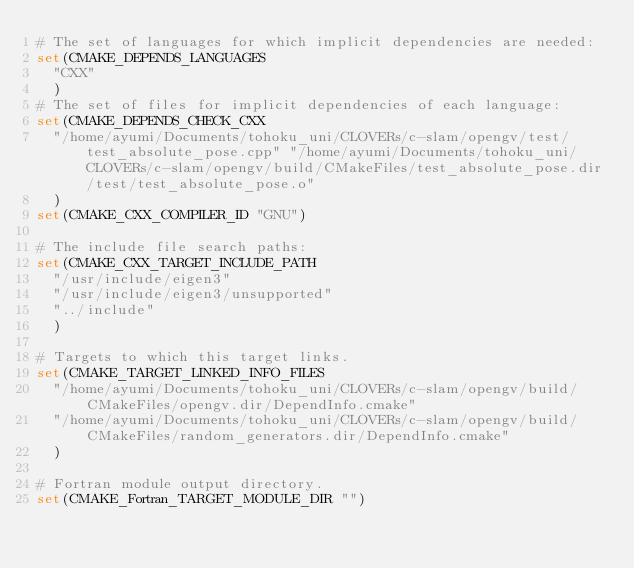<code> <loc_0><loc_0><loc_500><loc_500><_CMake_># The set of languages for which implicit dependencies are needed:
set(CMAKE_DEPENDS_LANGUAGES
  "CXX"
  )
# The set of files for implicit dependencies of each language:
set(CMAKE_DEPENDS_CHECK_CXX
  "/home/ayumi/Documents/tohoku_uni/CLOVERs/c-slam/opengv/test/test_absolute_pose.cpp" "/home/ayumi/Documents/tohoku_uni/CLOVERs/c-slam/opengv/build/CMakeFiles/test_absolute_pose.dir/test/test_absolute_pose.o"
  )
set(CMAKE_CXX_COMPILER_ID "GNU")

# The include file search paths:
set(CMAKE_CXX_TARGET_INCLUDE_PATH
  "/usr/include/eigen3"
  "/usr/include/eigen3/unsupported"
  "../include"
  )

# Targets to which this target links.
set(CMAKE_TARGET_LINKED_INFO_FILES
  "/home/ayumi/Documents/tohoku_uni/CLOVERs/c-slam/opengv/build/CMakeFiles/opengv.dir/DependInfo.cmake"
  "/home/ayumi/Documents/tohoku_uni/CLOVERs/c-slam/opengv/build/CMakeFiles/random_generators.dir/DependInfo.cmake"
  )

# Fortran module output directory.
set(CMAKE_Fortran_TARGET_MODULE_DIR "")
</code> 